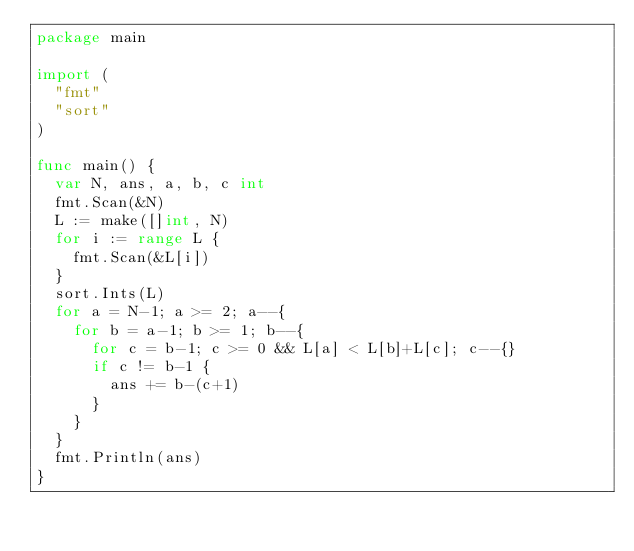<code> <loc_0><loc_0><loc_500><loc_500><_Go_>package main

import (
  "fmt"
  "sort"
)

func main() {
  var N, ans, a, b, c int
  fmt.Scan(&N)
  L := make([]int, N)
  for i := range L {
    fmt.Scan(&L[i])
  }
  sort.Ints(L)
  for a = N-1; a >= 2; a--{
    for b = a-1; b >= 1; b--{
      for c = b-1; c >= 0 && L[a] < L[b]+L[c]; c--{}
      if c != b-1 {
        ans += b-(c+1)
      }
    }
  }
  fmt.Println(ans)
}
</code> 